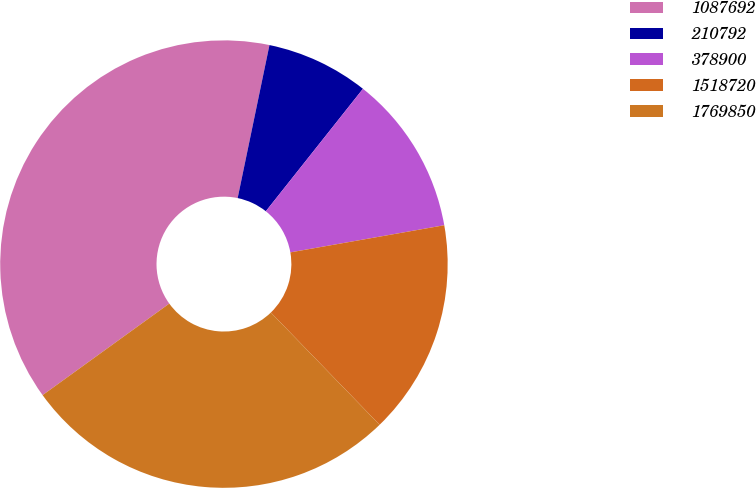Convert chart. <chart><loc_0><loc_0><loc_500><loc_500><pie_chart><fcel>1087692<fcel>210792<fcel>378900<fcel>1518720<fcel>1769850<nl><fcel>38.22%<fcel>7.41%<fcel>11.55%<fcel>15.53%<fcel>27.29%<nl></chart> 